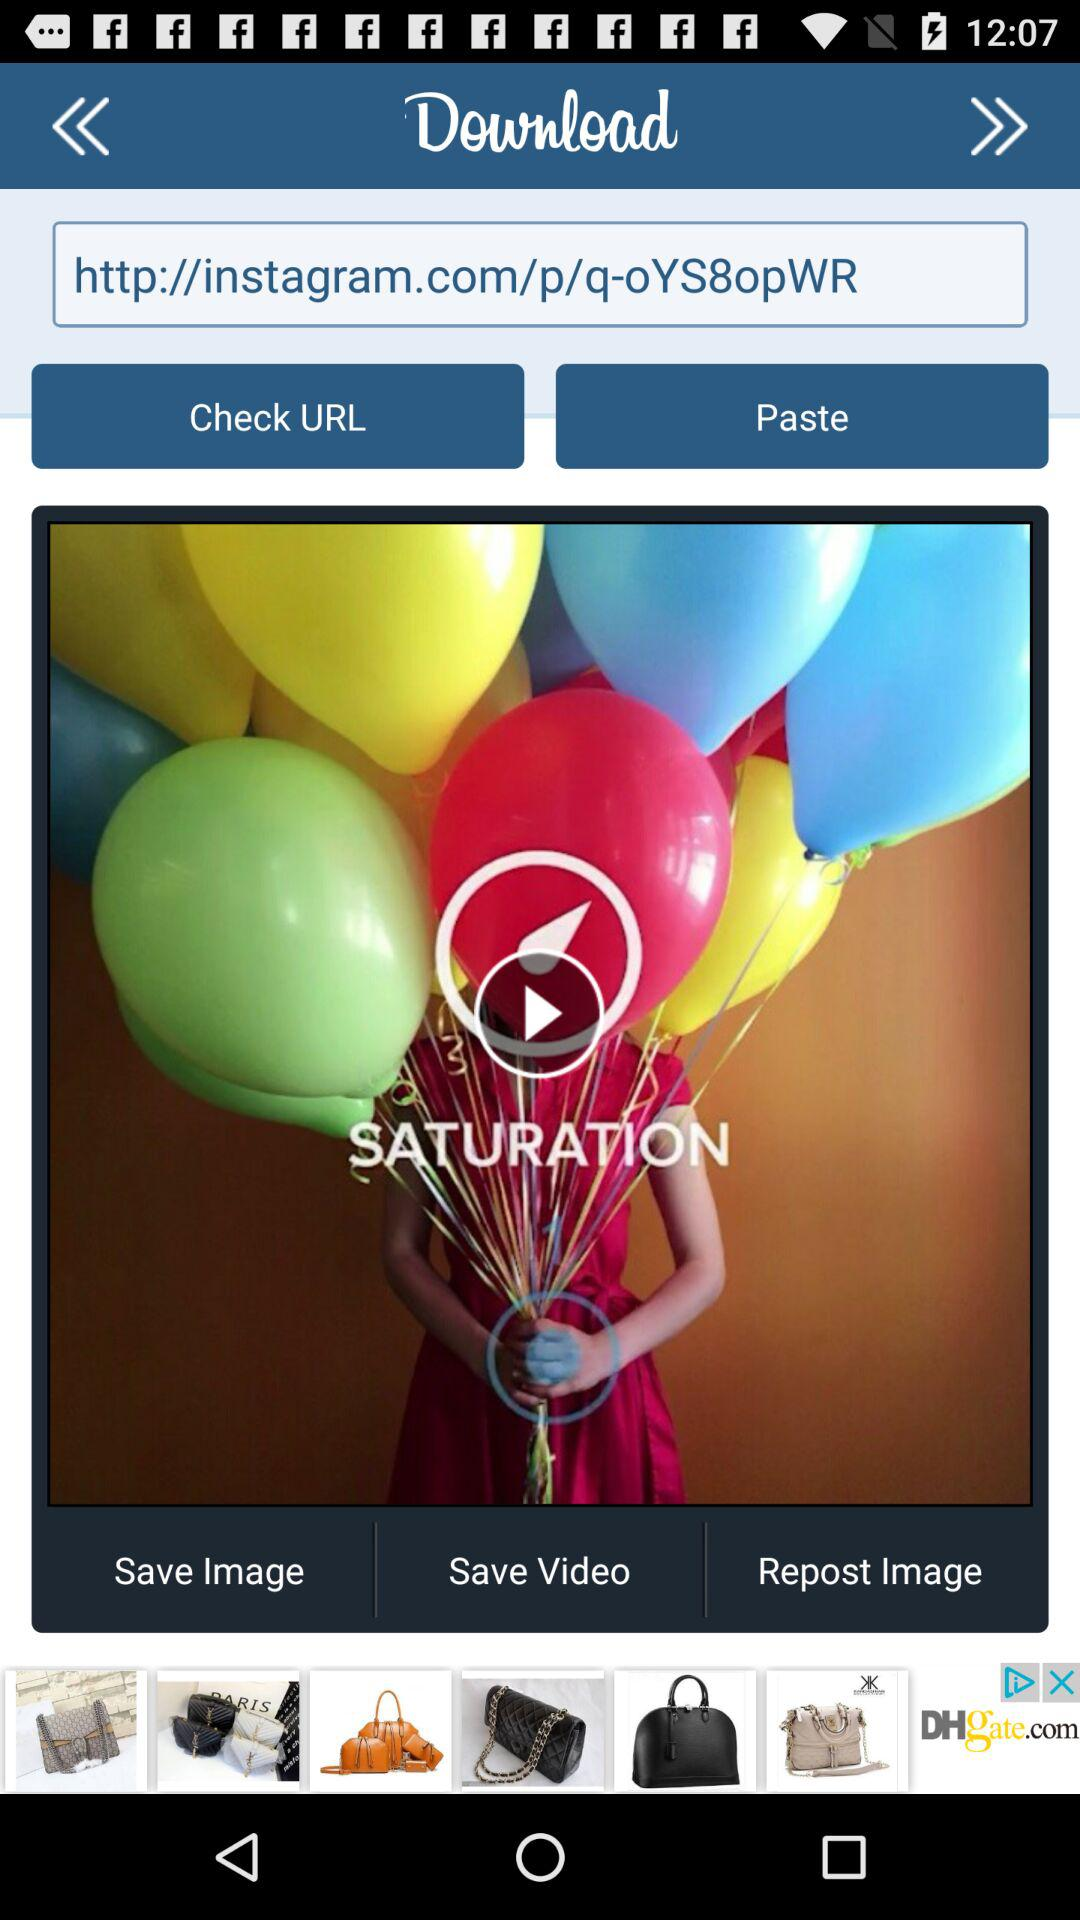What is the name of the video shown on the screen? The name of the video shown on the screen is "SATURATION". 